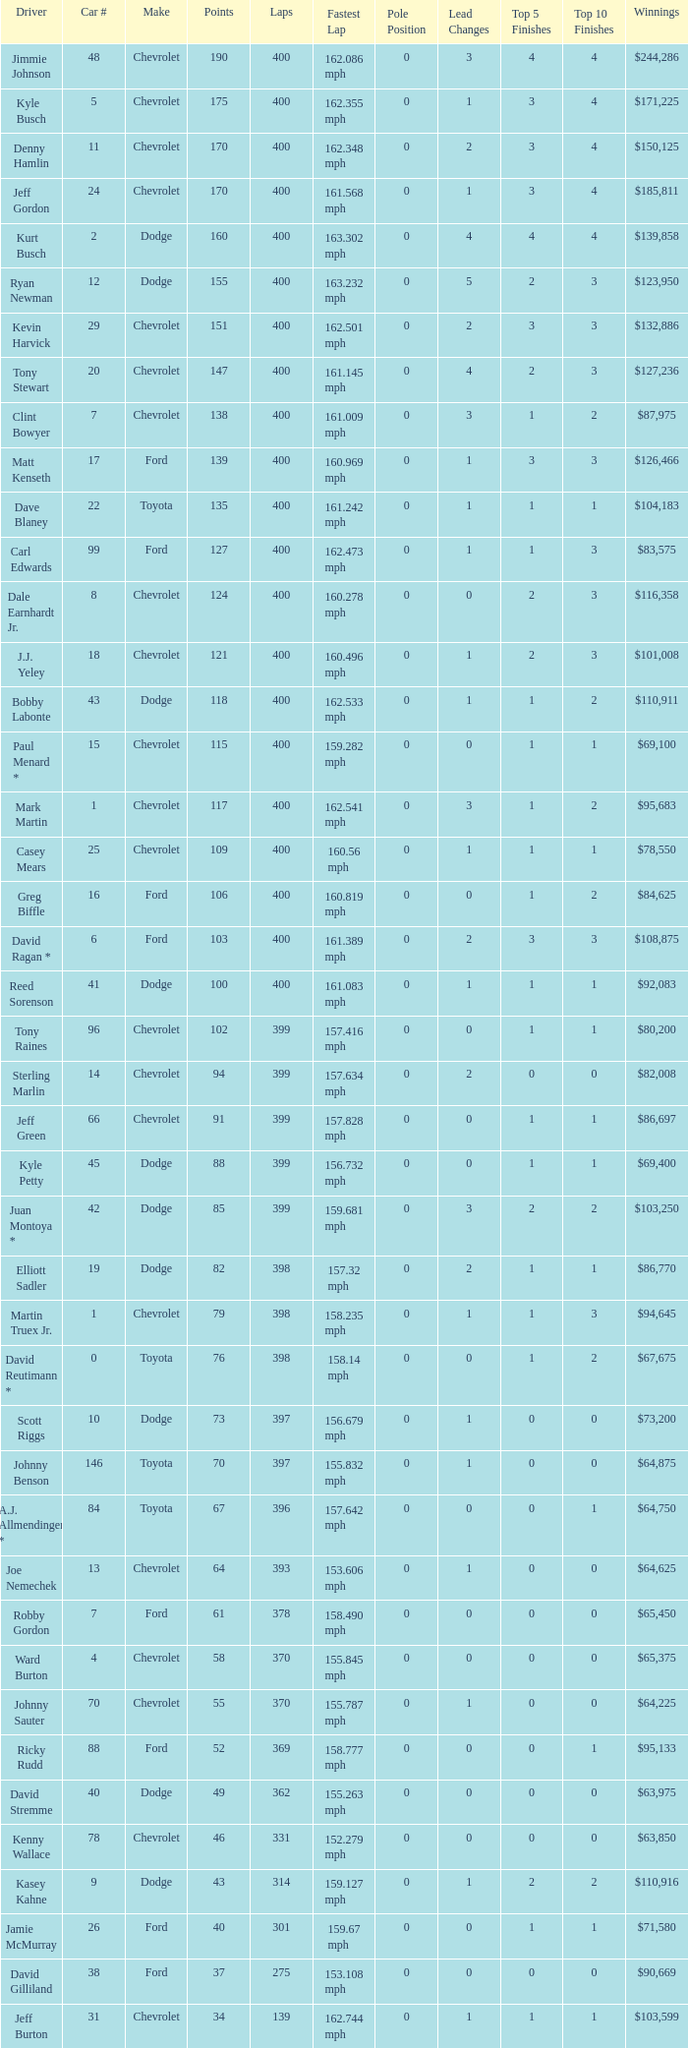Parse the full table. {'header': ['Driver', 'Car #', 'Make', 'Points', 'Laps', 'Fastest Lap', 'Pole Position', 'Lead Changes', 'Top 5 Finishes', 'Top 10 Finishes', 'Winnings'], 'rows': [['Jimmie Johnson', '48', 'Chevrolet', '190', '400', '162.086 mph', '0', '3', '4', '4', '$244,286'], ['Kyle Busch', '5', 'Chevrolet', '175', '400', '162.355 mph', '0', '1', '3', '4', '$171,225'], ['Denny Hamlin', '11', 'Chevrolet', '170', '400', '162.348 mph', '0', '2', '3', '4', '$150,125'], ['Jeff Gordon', '24', 'Chevrolet', '170', '400', '161.568 mph', '0', '1', '3', '4', '$185,811'], ['Kurt Busch', '2', 'Dodge', '160', '400', '163.302 mph', '0', '4', '4', '4', '$139,858'], ['Ryan Newman', '12', 'Dodge', '155', '400', '163.232 mph', '0', '5', '2', '3', '$123,950'], ['Kevin Harvick', '29', 'Chevrolet', '151', '400', '162.501 mph', '0', '2', '3', '3', '$132,886'], ['Tony Stewart', '20', 'Chevrolet', '147', '400', '161.145 mph', '0', '4', '2', '3', '$127,236'], ['Clint Bowyer', '7', 'Chevrolet', '138', '400', '161.009 mph', '0', '3', '1', '2', '$87,975'], ['Matt Kenseth', '17', 'Ford', '139', '400', '160.969 mph', '0', '1', '3', '3', '$126,466'], ['Dave Blaney', '22', 'Toyota', '135', '400', '161.242 mph', '0', '1', '1', '1', '$104,183'], ['Carl Edwards', '99', 'Ford', '127', '400', '162.473 mph', '0', '1', '1', '3', '$83,575'], ['Dale Earnhardt Jr.', '8', 'Chevrolet', '124', '400', '160.278 mph', '0', '0', '2', '3', '$116,358'], ['J.J. Yeley', '18', 'Chevrolet', '121', '400', '160.496 mph', '0', '1', '2', '3', '$101,008'], ['Bobby Labonte', '43', 'Dodge', '118', '400', '162.533 mph', '0', '1', '1', '2', '$110,911'], ['Paul Menard *', '15', 'Chevrolet', '115', '400', '159.282 mph', '0', '0', '1', '1', '$69,100'], ['Mark Martin', '1', 'Chevrolet', '117', '400', '162.541 mph', '0', '3', '1', '2', '$95,683'], ['Casey Mears', '25', 'Chevrolet', '109', '400', '160.56 mph', '0', '1', '1', '1', '$78,550'], ['Greg Biffle', '16', 'Ford', '106', '400', '160.819 mph', '0', '0', '1', '2', '$84,625'], ['David Ragan *', '6', 'Ford', '103', '400', '161.389 mph', '0', '2', '3', '3', '$108,875'], ['Reed Sorenson', '41', 'Dodge', '100', '400', '161.083 mph', '0', '1', '1', '1', '$92,083'], ['Tony Raines', '96', 'Chevrolet', '102', '399', '157.416 mph', '0', '0', '1', '1', '$80,200'], ['Sterling Marlin', '14', 'Chevrolet', '94', '399', '157.634 mph', '0', '2', '0', '0', '$82,008'], ['Jeff Green', '66', 'Chevrolet', '91', '399', '157.828 mph', '0', '0', '1', '1', '$86,697'], ['Kyle Petty', '45', 'Dodge', '88', '399', '156.732 mph', '0', '0', '1', '1', '$69,400'], ['Juan Montoya *', '42', 'Dodge', '85', '399', '159.681 mph', '0', '3', '2', '2', '$103,250'], ['Elliott Sadler', '19', 'Dodge', '82', '398', '157.32 mph', '0', '2', '1', '1', '$86,770'], ['Martin Truex Jr.', '1', 'Chevrolet', '79', '398', '158.235 mph', '0', '1', '1', '3', '$94,645'], ['David Reutimann *', '0', 'Toyota', '76', '398', '158.14 mph', '0', '0', '1', '2', '$67,675'], ['Scott Riggs', '10', 'Dodge', '73', '397', '156.679 mph', '0', '1', '0', '0', '$73,200'], ['Johnny Benson', '146', 'Toyota', '70', '397', '155.832 mph', '0', '1', '0', '0', '$64,875'], ['A.J. Allmendinger *', '84', 'Toyota', '67', '396', '157.642 mph', '0', '0', '0', '1', '$64,750'], ['Joe Nemechek', '13', 'Chevrolet', '64', '393', '153.606 mph', '0', '1', '0', '0', '$64,625'], ['Robby Gordon', '7', 'Ford', '61', '378', '158.490 mph', '0', '0', '0', '0', '$65,450'], ['Ward Burton', '4', 'Chevrolet', '58', '370', '155.845 mph', '0', '0', '0', '0', '$65,375'], ['Johnny Sauter', '70', 'Chevrolet', '55', '370', '155.787 mph', '0', '1', '0', '0', '$64,225'], ['Ricky Rudd', '88', 'Ford', '52', '369', '158.777 mph', '0', '0', '0', '1', '$95,133'], ['David Stremme', '40', 'Dodge', '49', '362', '155.263 mph', '0', '0', '0', '0', '$63,975'], ['Kenny Wallace', '78', 'Chevrolet', '46', '331', '152.279 mph', '0', '0', '0', '0', '$63,850'], ['Kasey Kahne', '9', 'Dodge', '43', '314', '159.127 mph', '0', '1', '2', '2', '$110,916'], ['Jamie McMurray', '26', 'Ford', '40', '301', '159.67 mph', '0', '0', '1', '1', '$71,580'], ['David Gilliland', '38', 'Ford', '37', '275', '153.108 mph', '0', '0', '0', '0', '$90,669'], ['Jeff Burton', '31', 'Chevrolet', '34', '139', '162.744 mph', '0', '1', '1', '1', '$103,599']]} What is the car number that has less than 369 laps for a Dodge with more than 49 points? None. 